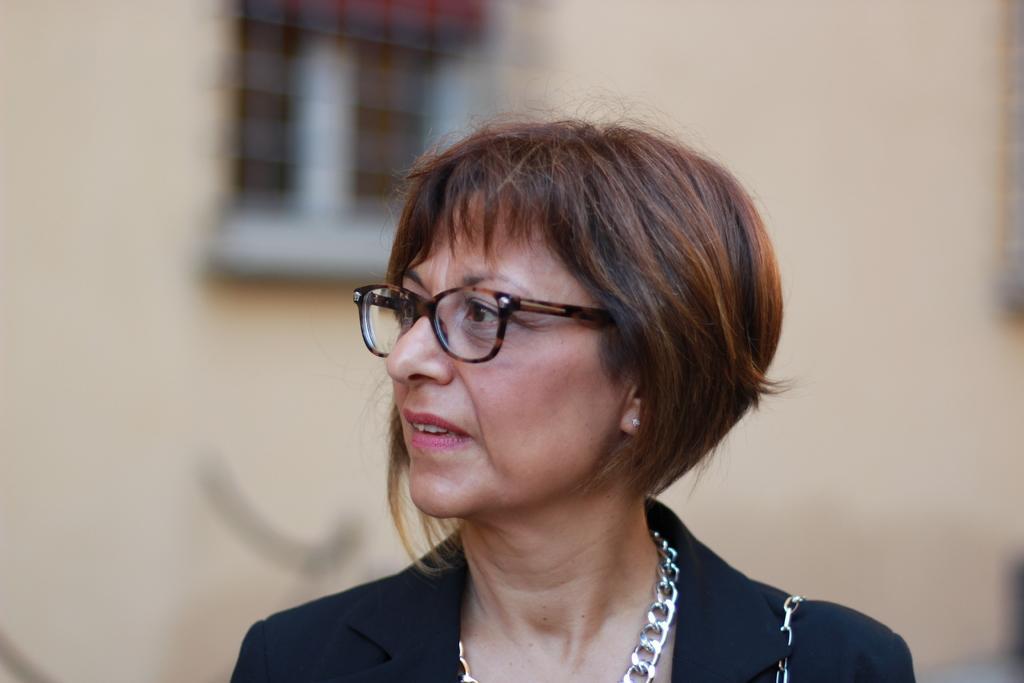Could you give a brief overview of what you see in this image? In this image we can see a woman wearing the glasses and the background is blurred with the plain wall and also an object. 